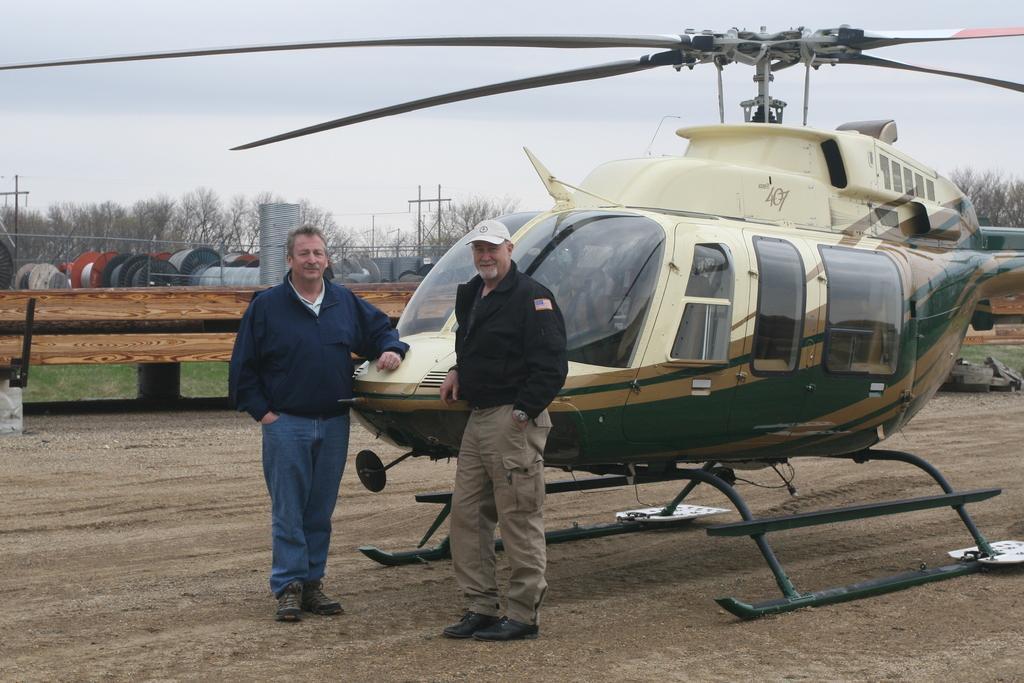In one or two sentences, can you explain what this image depicts? In this image, we can see two people are standing and watching. They are smiling. Here we can see a helicopter on the ground. Background there are so many trees, poles, wires, some objects and sky. 